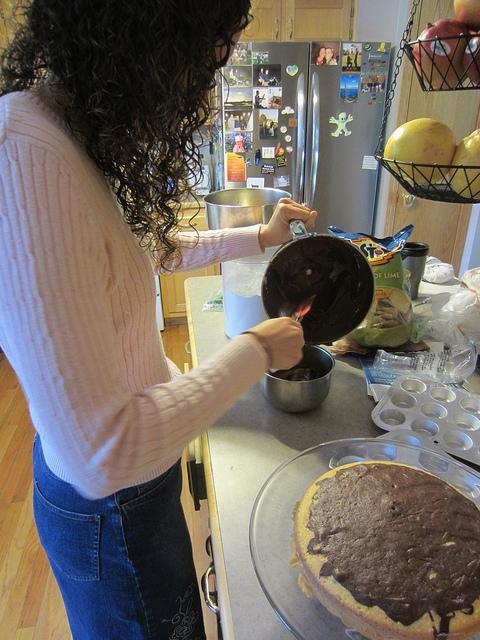How was the item on the plate cooked?

Choices:
A) microwave
B) open flame
C) oven
D) stovetop oven 